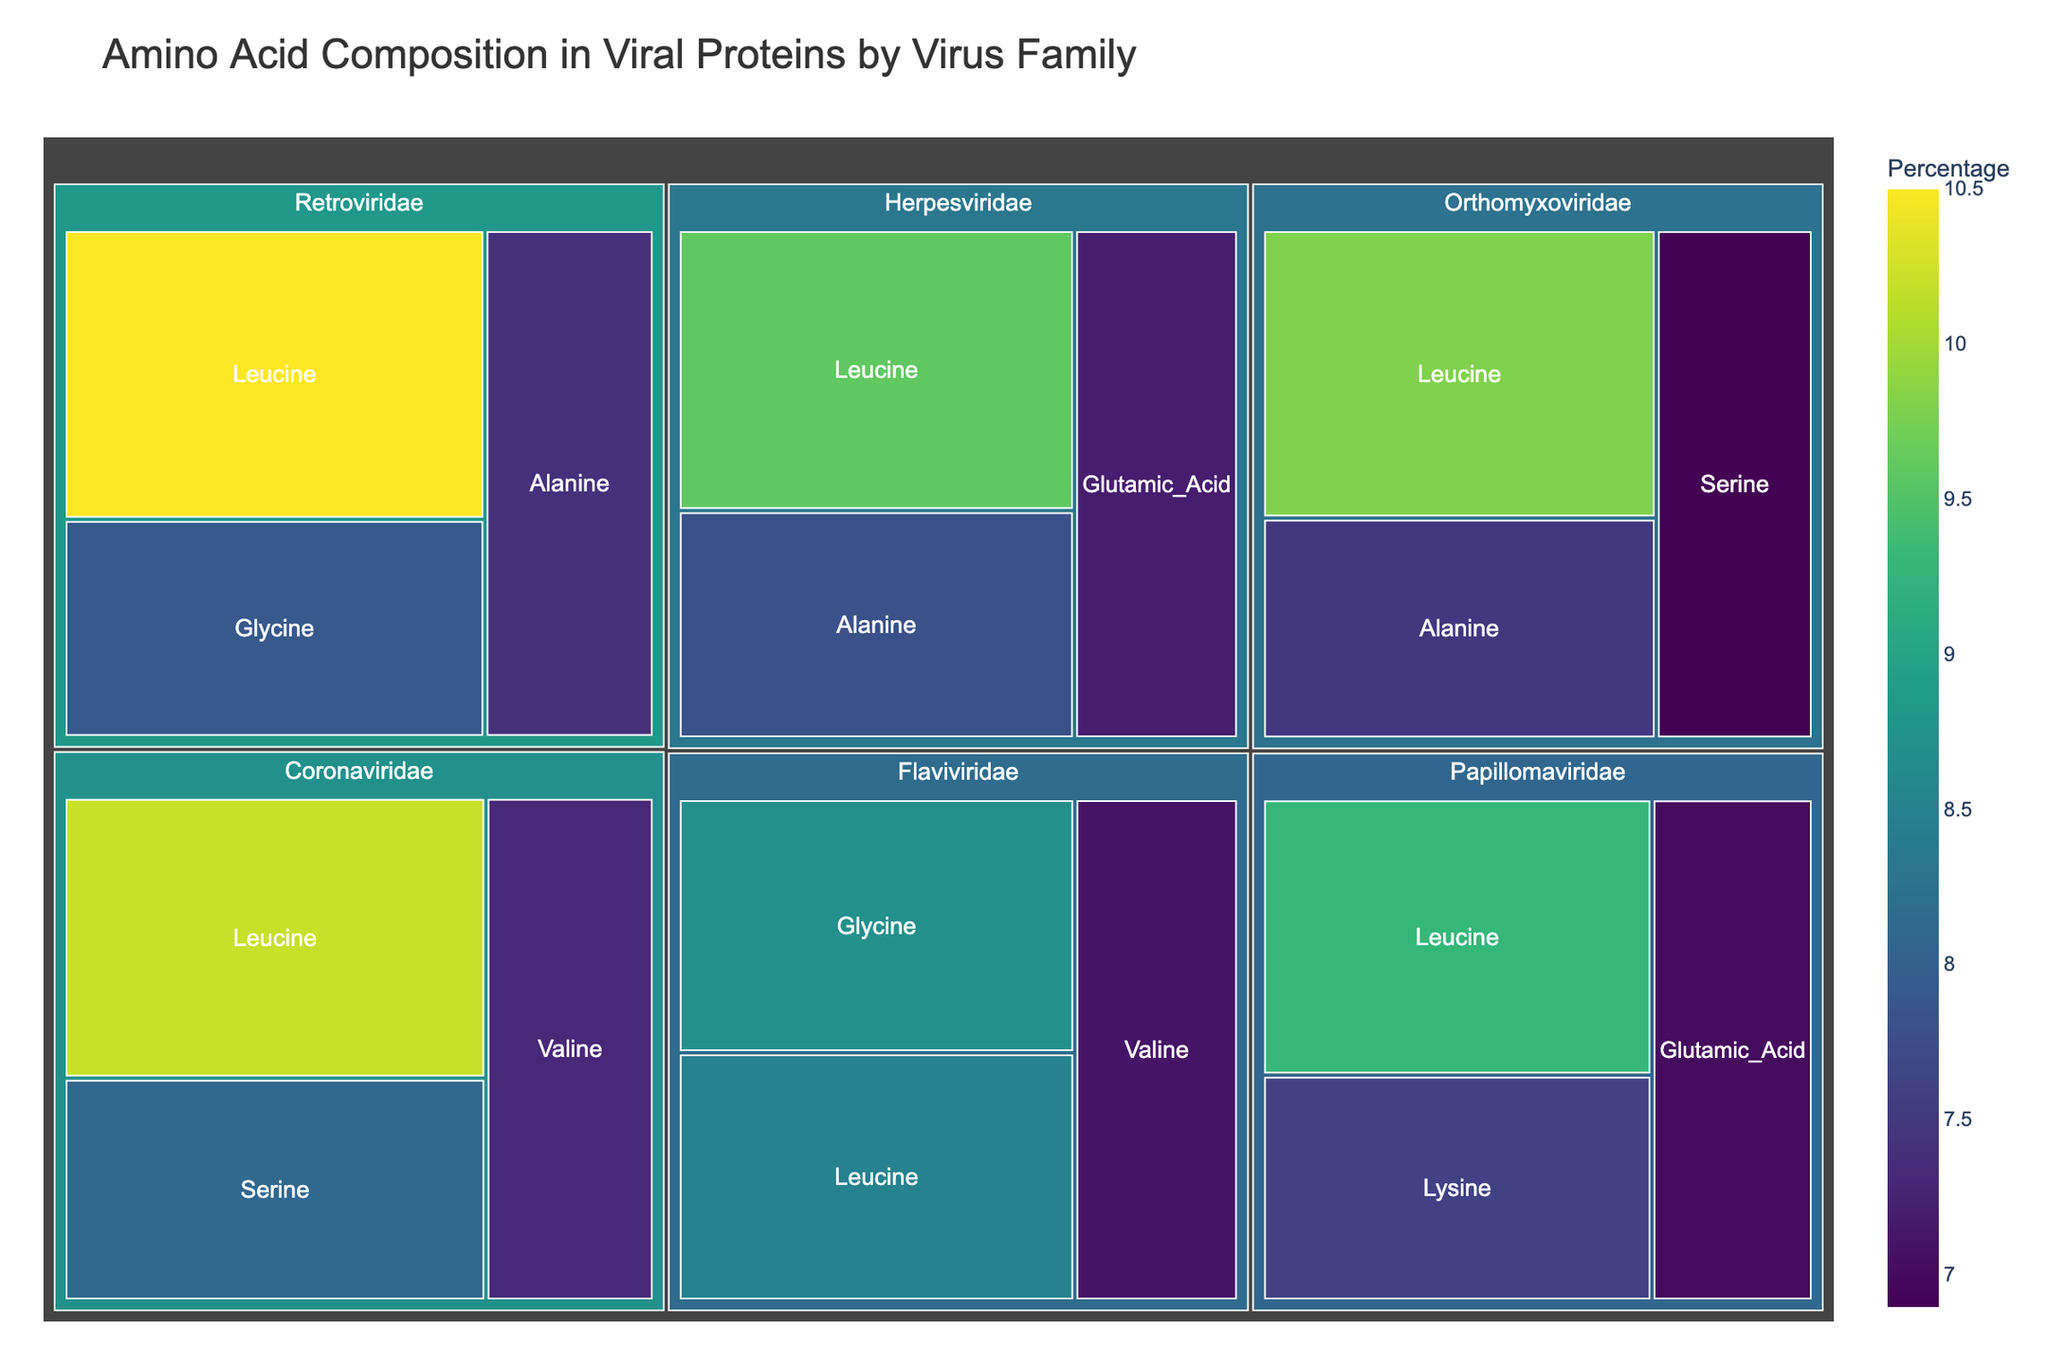What is the title of the treemap? The title of the treemap is usually found at the top. In this case, it clearly states the content of the figure.
Answer: Amino Acid Composition in Viral Proteins by Virus Family Which virus family has the highest percentage of Leucine? To determine this, look for the Leucine sections within each virus family and compare their percentages.
Answer: Retroviridae How many virus families are represented in the treemap? Count the distinct large sections designated for each virus family.
Answer: Six What is the percentage of Alanine in the Herpesviridae family? Locate the Herpesviridae section and find the corresponding segment for Alanine. The percentage is directly shown on the segment.
Answer: 7.8% Which virus family has the highest percentage of Glycine? Identify all Glycine sections and compare their percentages across different virus families.
Answer: Flaviviridae What is the total percentage of Valine across all virus families? Sum the Valine percentages from the various virus families: Coronaviridae (7.3%) and Flaviviridae (7.1%).
Answer: 14.4% How does the percentage of Serine in the Orthomyxoviridae family compare to that in the Coronaviridae family? Compare the percentages of Serine in Orthomyxoviridae (6.9%) and Coronaviridae (8.1%).
Answer: Lower in Orthomyxoviridae Which amino acid appears most frequently across all virus families? Count the occurrence of each amino acid name across different virus families.
Answer: Leucine Is there any virus family where Glutamic Acid makes up more than 7% of its composition? Check the segments for Glutamic Acid in each virus family and see if any percentage exceeds 7%.
Answer: Yes, Herpesviridae Which virus family has the lowest percentage of an amino acid, and what is that amino acid? Identify the amino acid segments with the lowest percentage values and note their virus families.
Answer: Papillomaviridae, Glutamic Acid (7.0%) 